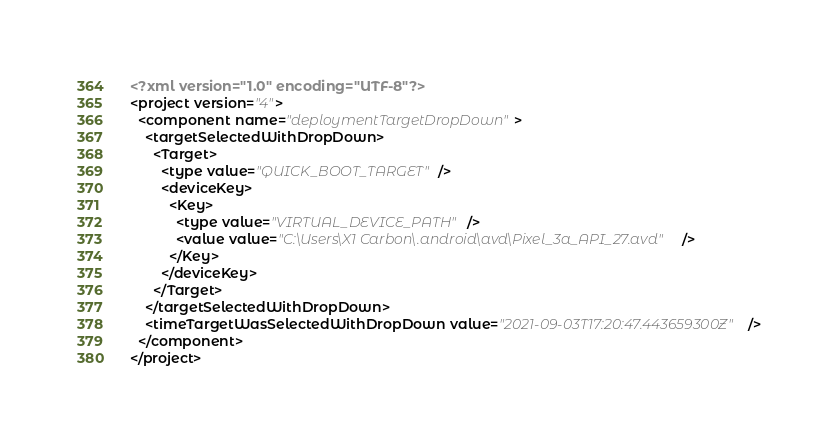<code> <loc_0><loc_0><loc_500><loc_500><_XML_><?xml version="1.0" encoding="UTF-8"?>
<project version="4">
  <component name="deploymentTargetDropDown">
    <targetSelectedWithDropDown>
      <Target>
        <type value="QUICK_BOOT_TARGET" />
        <deviceKey>
          <Key>
            <type value="VIRTUAL_DEVICE_PATH" />
            <value value="C:\Users\X1 Carbon\.android\avd\Pixel_3a_API_27.avd" />
          </Key>
        </deviceKey>
      </Target>
    </targetSelectedWithDropDown>
    <timeTargetWasSelectedWithDropDown value="2021-09-03T17:20:47.443659300Z" />
  </component>
</project></code> 